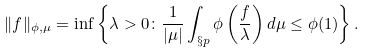Convert formula to latex. <formula><loc_0><loc_0><loc_500><loc_500>\| f \| _ { \phi , \mu } = \inf \left \{ \lambda > 0 \colon \frac { 1 } { | \mu | } \int _ { \S p } \phi \left ( \frac { f } { \lambda } \right ) d \mu \leq \phi ( 1 ) \right \} .</formula> 